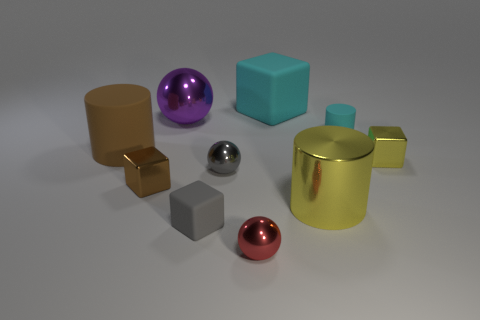What is the material of the brown object that is the same shape as the small yellow thing?
Your answer should be very brief. Metal. What color is the cylinder that is on the left side of the large cyan rubber object?
Make the answer very short. Brown. Are there more metal cubes to the left of the big purple ball than large green rubber blocks?
Give a very brief answer. Yes. What is the color of the small matte cylinder?
Make the answer very short. Cyan. There is a big matte object in front of the small cyan rubber cylinder behind the big rubber object that is to the left of the purple metal ball; what shape is it?
Make the answer very short. Cylinder. The cube that is in front of the cyan matte cylinder and behind the small gray shiny object is made of what material?
Give a very brief answer. Metal. What shape is the cyan thing that is left of the big cylinder that is in front of the tiny yellow metallic object?
Provide a short and direct response. Cube. Is there any other thing that has the same color as the big metallic ball?
Your answer should be compact. No. Is the size of the brown cylinder the same as the matte cylinder right of the small red shiny object?
Ensure brevity in your answer.  No. How many large objects are either purple shiny balls or gray balls?
Keep it short and to the point. 1. 